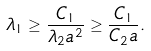<formula> <loc_0><loc_0><loc_500><loc_500>\lambda _ { 1 } \geq \frac { C _ { 1 } } { \lambda _ { 2 } a ^ { 2 } } \geq \frac { C _ { 1 } } { C _ { 2 } a } .</formula> 